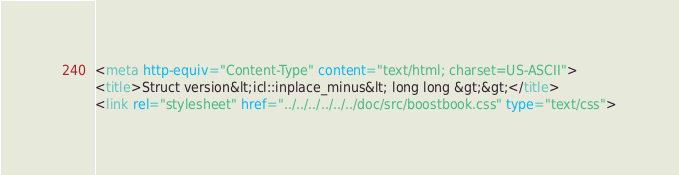Convert code to text. <code><loc_0><loc_0><loc_500><loc_500><_HTML_><meta http-equiv="Content-Type" content="text/html; charset=US-ASCII">
<title>Struct version&lt;icl::inplace_minus&lt; long long &gt;&gt;</title>
<link rel="stylesheet" href="../../../../../../doc/src/boostbook.css" type="text/css"></code> 